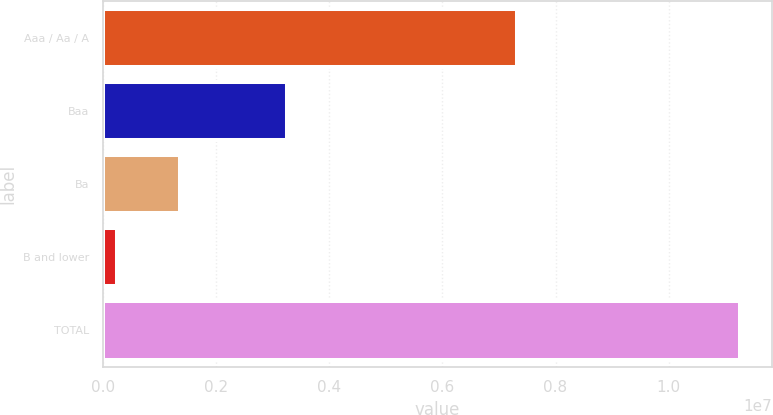Convert chart. <chart><loc_0><loc_0><loc_500><loc_500><bar_chart><fcel>Aaa / Aa / A<fcel>Baa<fcel>Ba<fcel>B and lower<fcel>TOTAL<nl><fcel>7.31421e+06<fcel>3.2555e+06<fcel>1.36145e+06<fcel>261258<fcel>1.12632e+07<nl></chart> 